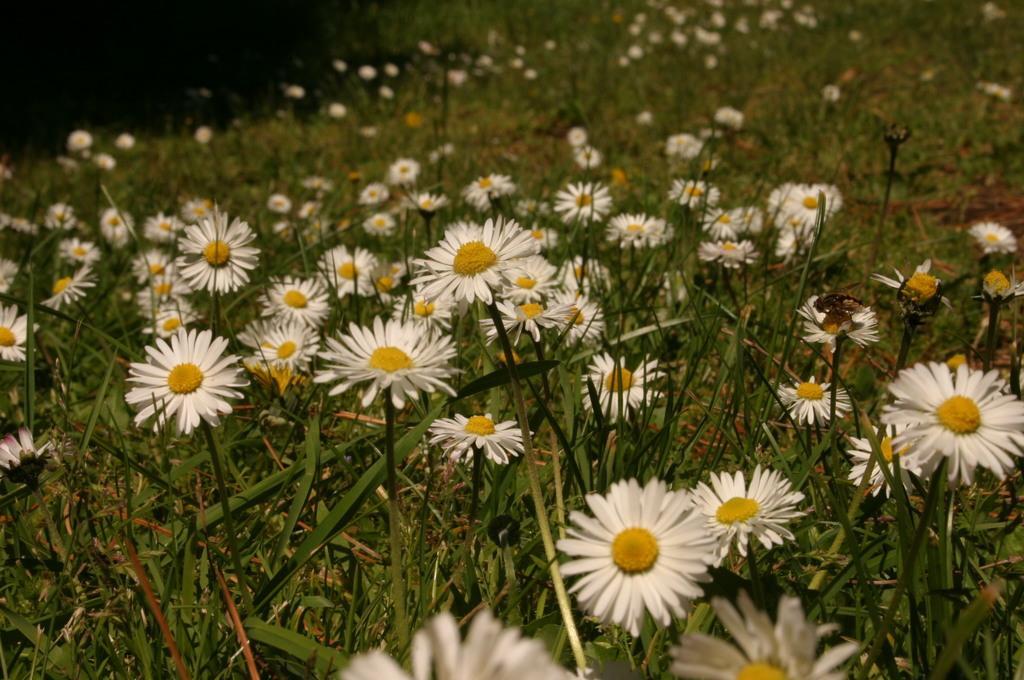In one or two sentences, can you explain what this image depicts? In this image we can see plants and flowers. 